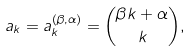<formula> <loc_0><loc_0><loc_500><loc_500>a _ { k } = a _ { k } ^ { ( \beta , \alpha ) } = { \beta k + \alpha \choose k } ,</formula> 